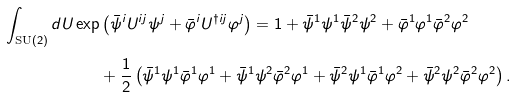Convert formula to latex. <formula><loc_0><loc_0><loc_500><loc_500>\int _ { \text {SU} ( 2 ) } d U \exp & \left ( \bar { \psi } ^ { i } U ^ { i j } \psi ^ { j } + \bar { \varphi } ^ { i } U ^ { \dagger i j } \varphi ^ { j } \right ) = 1 + \bar { \psi } ^ { 1 } \psi ^ { 1 } \bar { \psi } ^ { 2 } \psi ^ { 2 } + \bar { \varphi } ^ { 1 } \varphi ^ { 1 } \bar { \varphi } ^ { 2 } \varphi ^ { 2 } \\ & + \frac { 1 } { 2 } \left ( \bar { \psi } ^ { 1 } \psi ^ { 1 } \bar { \varphi } ^ { 1 } \varphi ^ { 1 } + \bar { \psi } ^ { 1 } \psi ^ { 2 } \bar { \varphi } ^ { 2 } \varphi ^ { 1 } + \bar { \psi } ^ { 2 } \psi ^ { 1 } \bar { \varphi } ^ { 1 } \varphi ^ { 2 } + \bar { \psi } ^ { 2 } \psi ^ { 2 } \bar { \varphi } ^ { 2 } \varphi ^ { 2 } \right ) .</formula> 